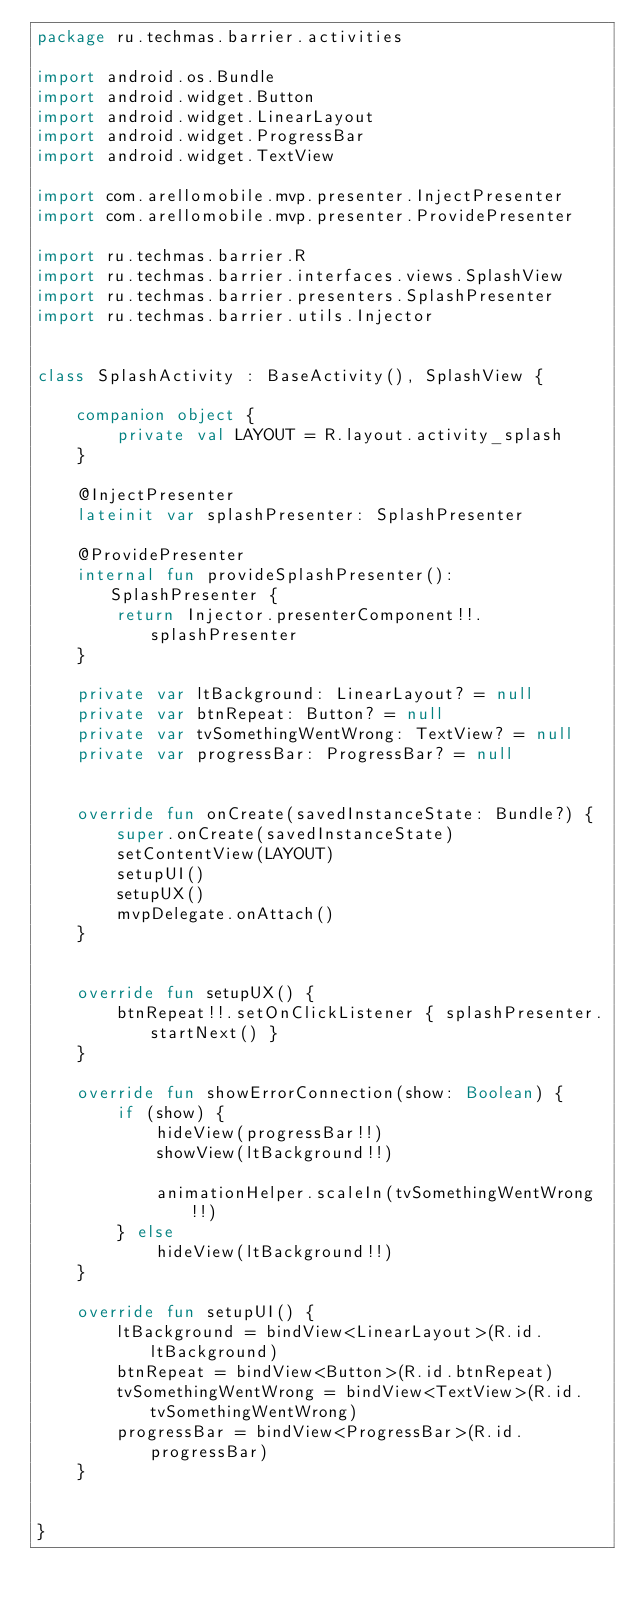<code> <loc_0><loc_0><loc_500><loc_500><_Kotlin_>package ru.techmas.barrier.activities

import android.os.Bundle
import android.widget.Button
import android.widget.LinearLayout
import android.widget.ProgressBar
import android.widget.TextView

import com.arellomobile.mvp.presenter.InjectPresenter
import com.arellomobile.mvp.presenter.ProvidePresenter

import ru.techmas.barrier.R
import ru.techmas.barrier.interfaces.views.SplashView
import ru.techmas.barrier.presenters.SplashPresenter
import ru.techmas.barrier.utils.Injector


class SplashActivity : BaseActivity(), SplashView {

    companion object {
        private val LAYOUT = R.layout.activity_splash
    }

    @InjectPresenter
    lateinit var splashPresenter: SplashPresenter

    @ProvidePresenter
    internal fun provideSplashPresenter(): SplashPresenter {
        return Injector.presenterComponent!!.splashPresenter
    }

    private var ltBackground: LinearLayout? = null
    private var btnRepeat: Button? = null
    private var tvSomethingWentWrong: TextView? = null
    private var progressBar: ProgressBar? = null


    override fun onCreate(savedInstanceState: Bundle?) {
        super.onCreate(savedInstanceState)
        setContentView(LAYOUT)
        setupUI()
        setupUX()
        mvpDelegate.onAttach()
    }


    override fun setupUX() {
        btnRepeat!!.setOnClickListener { splashPresenter.startNext() }
    }

    override fun showErrorConnection(show: Boolean) {
        if (show) {
            hideView(progressBar!!)
            showView(ltBackground!!)

            animationHelper.scaleIn(tvSomethingWentWrong!!)
        } else
            hideView(ltBackground!!)
    }

    override fun setupUI() {
        ltBackground = bindView<LinearLayout>(R.id.ltBackground)
        btnRepeat = bindView<Button>(R.id.btnRepeat)
        tvSomethingWentWrong = bindView<TextView>(R.id.tvSomethingWentWrong)
        progressBar = bindView<ProgressBar>(R.id.progressBar)
    }


}
</code> 